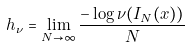<formula> <loc_0><loc_0><loc_500><loc_500>h _ { \nu } = \lim _ { N \rightarrow \infty } \frac { - \log \nu ( I _ { N } ( x ) ) } { N }</formula> 